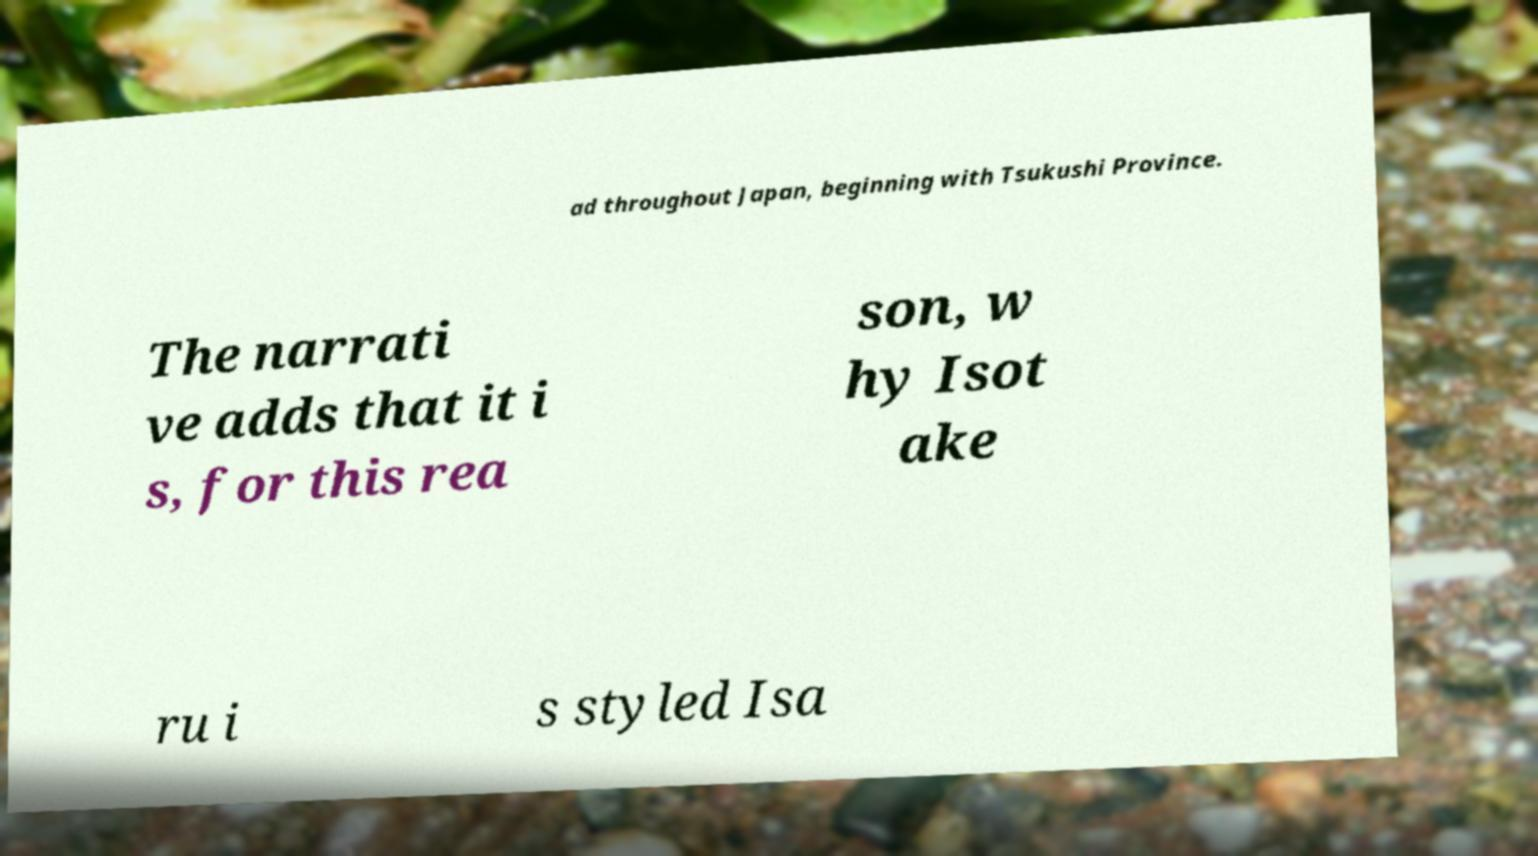Could you extract and type out the text from this image? ad throughout Japan, beginning with Tsukushi Province. The narrati ve adds that it i s, for this rea son, w hy Isot ake ru i s styled Isa 